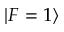Convert formula to latex. <formula><loc_0><loc_0><loc_500><loc_500>| F = 1 \rangle</formula> 